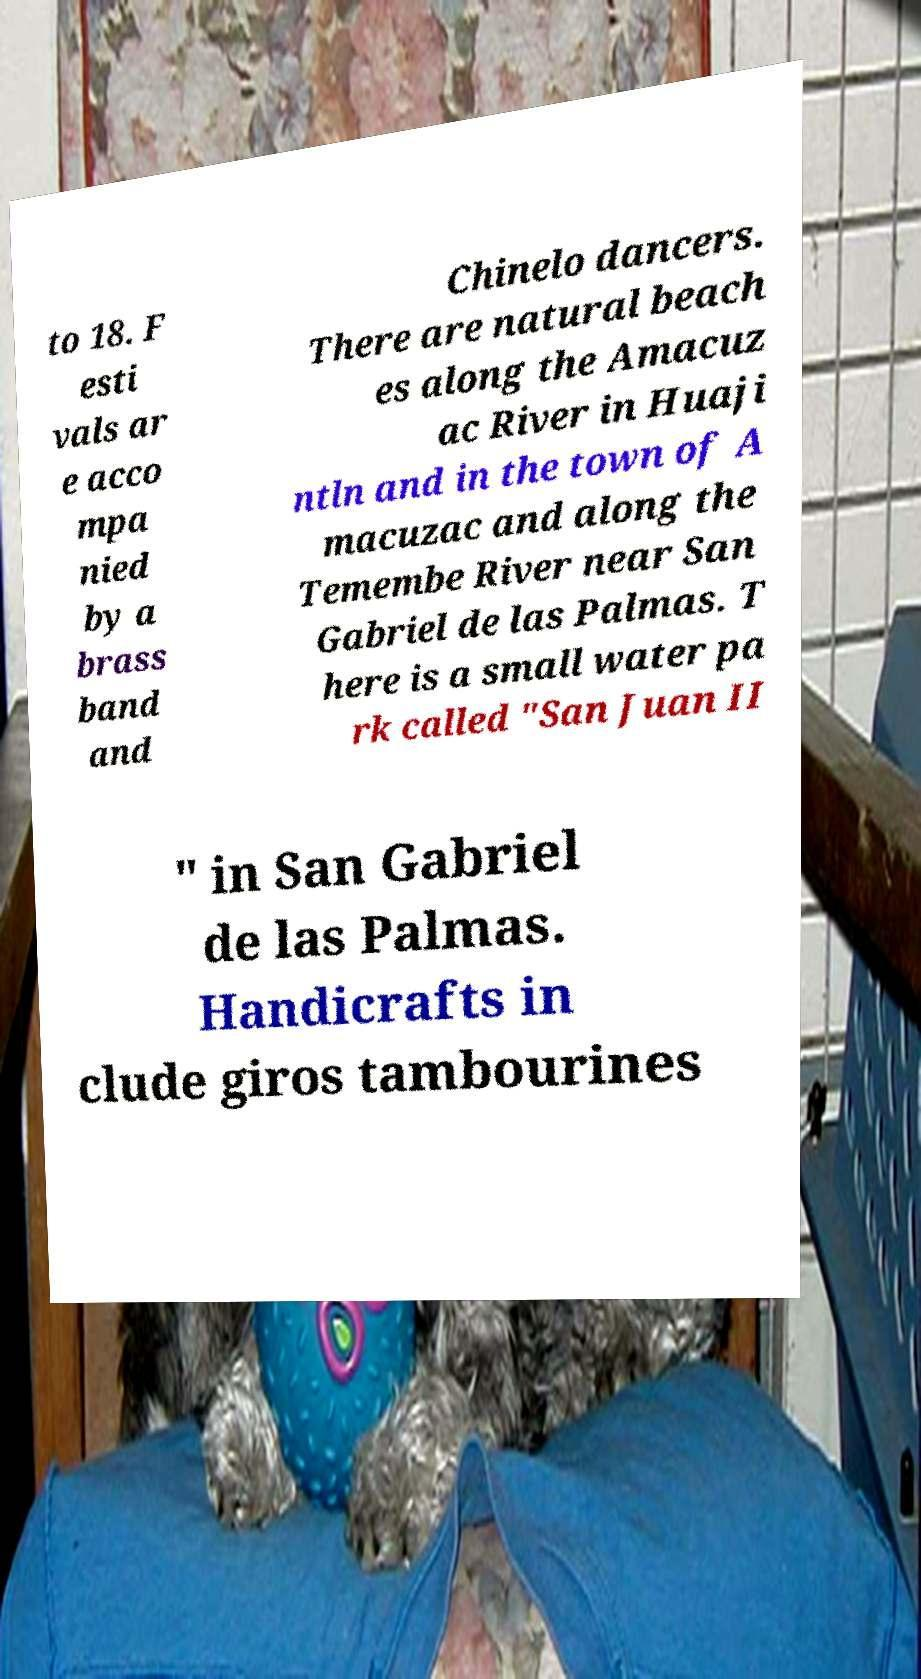What messages or text are displayed in this image? I need them in a readable, typed format. to 18. F esti vals ar e acco mpa nied by a brass band and Chinelo dancers. There are natural beach es along the Amacuz ac River in Huaji ntln and in the town of A macuzac and along the Temembe River near San Gabriel de las Palmas. T here is a small water pa rk called "San Juan II " in San Gabriel de las Palmas. Handicrafts in clude giros tambourines 